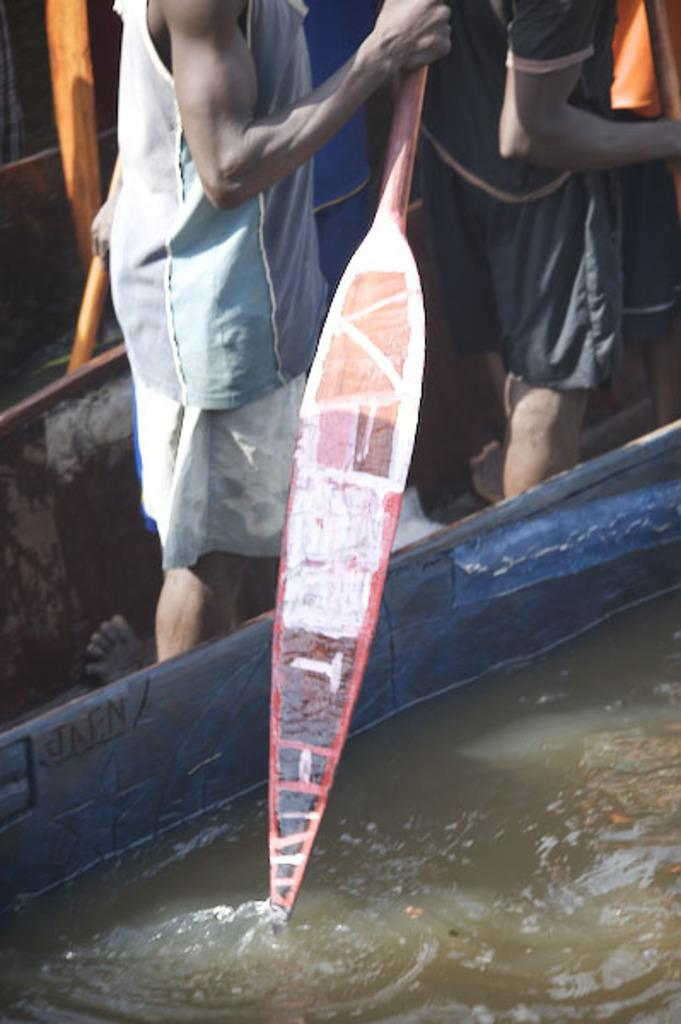What is the primary element present in the image? There is water in the image. What object is associated with the water in the image? There is a paddle in the image. Can you describe the people in the image? There are people in the image. What can be seen in the background of the image? There are objects visible in the background of the image. What type of can is being used to design a scarecrow in the image? There is no can or scarecrow present in the image. 